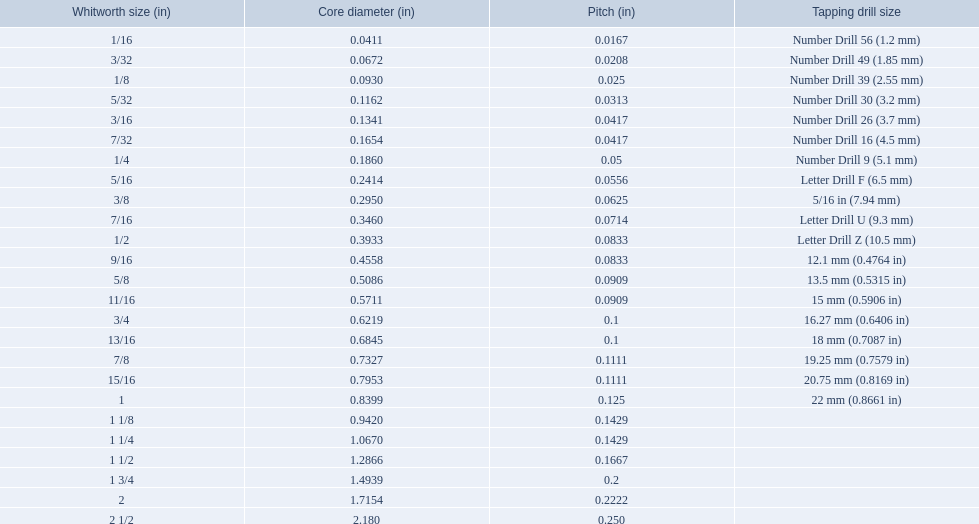What are all of the whitworth sizes in the british standard whitworth? 1/16, 3/32, 1/8, 5/32, 3/16, 7/32, 1/4, 5/16, 3/8, 7/16, 1/2, 9/16, 5/8, 11/16, 3/4, 13/16, 7/8, 15/16, 1, 1 1/8, 1 1/4, 1 1/2, 1 3/4, 2, 2 1/2. Which of these sizes uses a tapping drill size of 26? 3/16. 